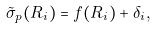<formula> <loc_0><loc_0><loc_500><loc_500>\tilde { \sigma } _ { p } ( R _ { i } ) = f ( R _ { i } ) + \delta _ { i } ,</formula> 